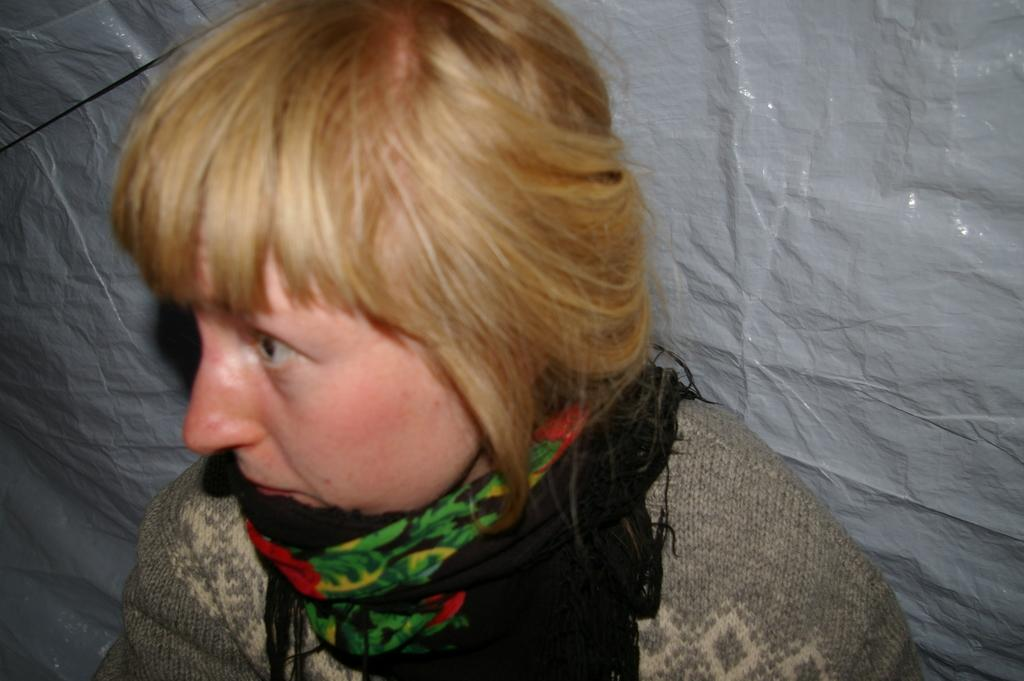What is the main subject of the image? There is a person in the image. What is the person wearing on their upper body? The person is wearing a gray shirt. What accessory is the person wearing around their neck? The person is wearing a black scarf. What color is the background of the image? The background of the image is white. What type of cloud can be seen in the image? There are no clouds present in the image; the background is white. What is the person teaching in the class depicted in the image? There is no class or teaching activity depicted in the image; it features a person wearing a gray shirt and a black scarf against a white background. 